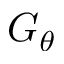Convert formula to latex. <formula><loc_0><loc_0><loc_500><loc_500>G _ { \theta }</formula> 